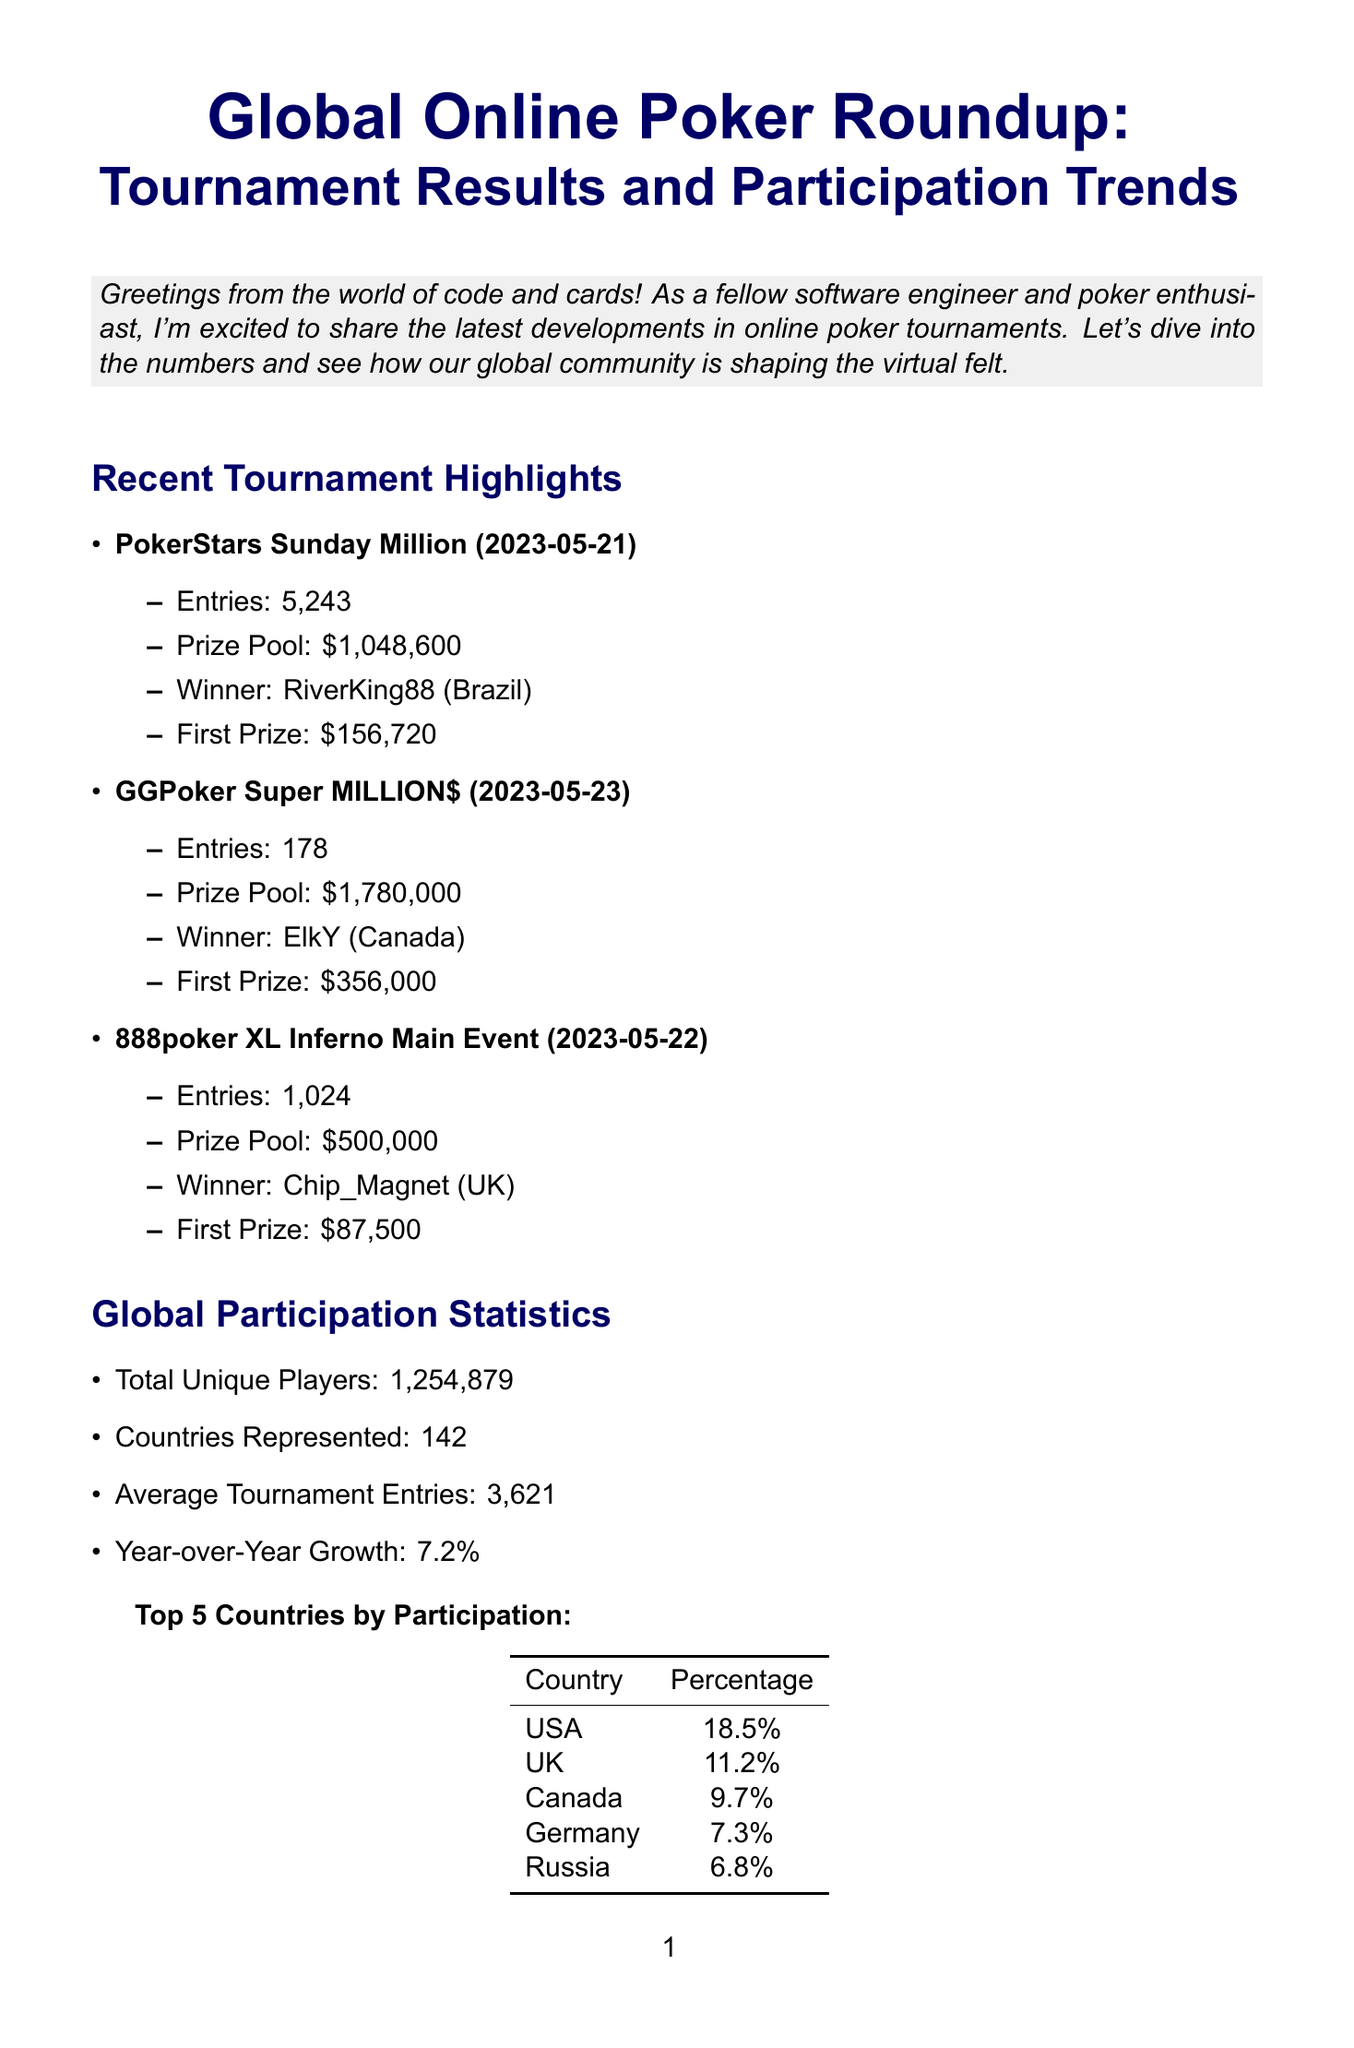What is the title of the newsletter? The title of the newsletter is stated at the beginning as "Global Online Poker Roundup: Tournament Results and Participation Trends."
Answer: Global Online Poker Roundup: Tournament Results and Participation Trends Who won the PokerStars Sunday Million? The winner of the PokerStars Sunday Million is mentioned as RiverKing88 from Brazil.
Answer: RiverKing88 (Brazil) What was the total unique players in the global participation stats? The document provides the total unique players as one million two hundred fifty-four thousand eight hundred seventy-nine.
Answer: 1,254,879 Which country had the highest percentage of participants? The document lists the USA as the country with the highest percentage of participants at eighteen point five percent.
Answer: USA How many entries were there in GGPoker Super MILLION$? The number of entries for the GGPoker Super MILLION$ is shown as one hundred seventy-eight.
Answer: 178 What is the guaranteed prize pool for SCOOP 2023 Main Event? The document specifies the guaranteed prize pool for the SCOOP 2023 Main Event as five million dollars.
Answer: $5,000,000 What percentage growth is reported year over year? The document states a year-over-year growth of seven point two percent in global participation statistics.
Answer: 7.2% Who is highlighted in the player spotlight? The player spotlight features Maria Konnikova, who is referenced as an author and psychology Ph.D. turned poker pro.
Answer: Maria Konnikova 